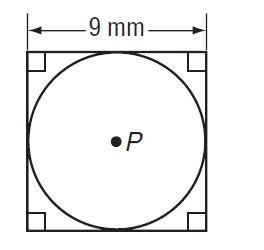Answer the mathemtical geometry problem and directly provide the correct option letter.
Question: Find the exact circumference of the circle.
Choices: A: 4.5 \pi B: 9 \pi C: 18 \pi D: 81 \pi B 